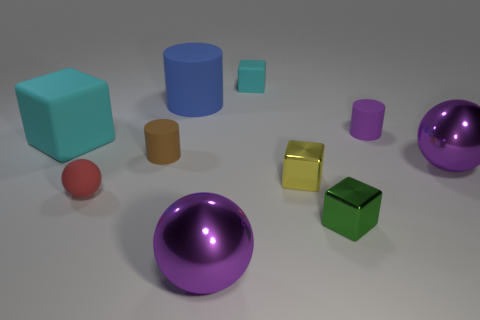Subtract all spheres. How many objects are left? 7 Add 7 big blue rubber things. How many big blue rubber things exist? 8 Subtract 0 red cylinders. How many objects are left? 10 Subtract all small blue matte cylinders. Subtract all tiny cyan blocks. How many objects are left? 9 Add 9 large cylinders. How many large cylinders are left? 10 